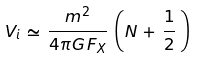Convert formula to latex. <formula><loc_0><loc_0><loc_500><loc_500>V _ { i } \, \simeq \, \frac { m ^ { 2 } } { 4 \pi G \, F _ { X } } \, \left ( N \, + \, \frac { 1 } { 2 } \, \right )</formula> 